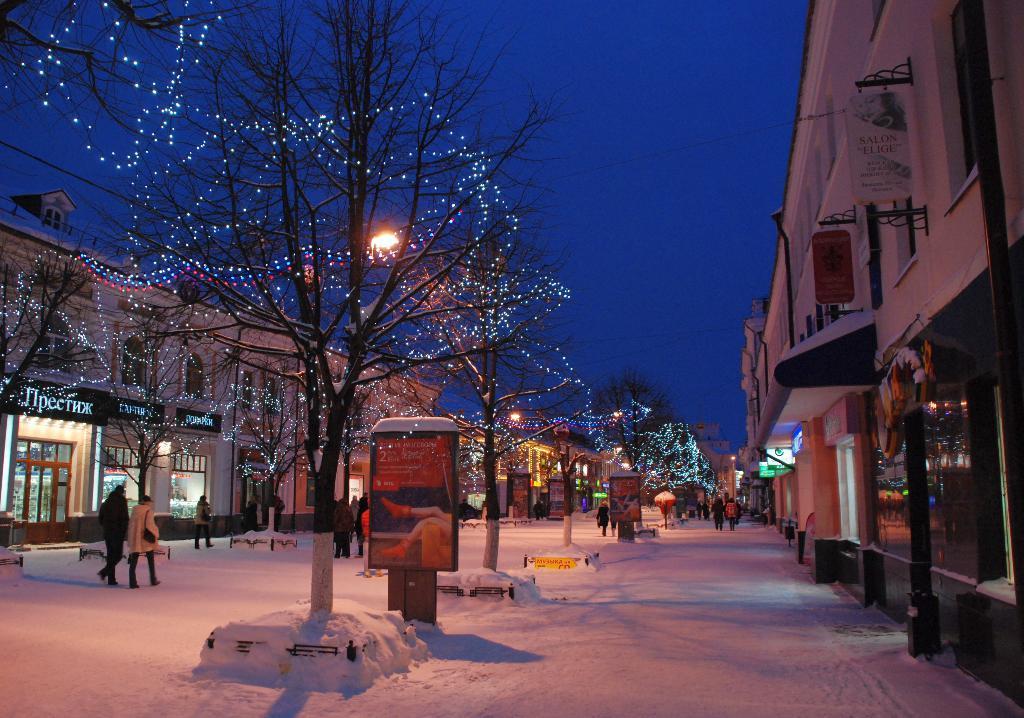How would you summarize this image in a sentence or two? In this picture we can see there are groups of people, street lights, snow and boards. There are trees with decorative lights. On the left and right side of the image, there are buildings with name boards. At the top of the image, there is the sky. 